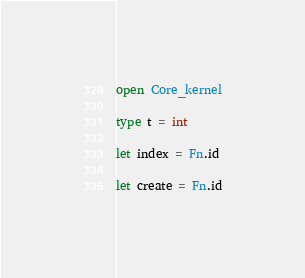Convert code to text. <code><loc_0><loc_0><loc_500><loc_500><_OCaml_>open Core_kernel

type t = int

let index = Fn.id

let create = Fn.id
</code> 